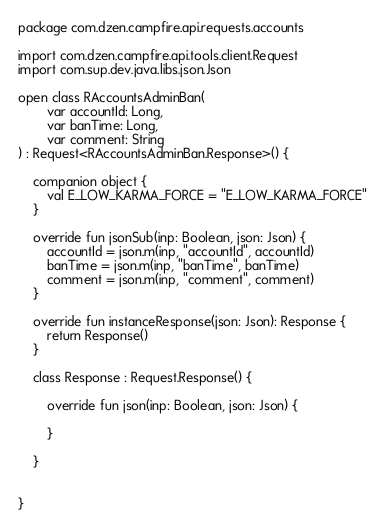<code> <loc_0><loc_0><loc_500><loc_500><_Kotlin_>package com.dzen.campfire.api.requests.accounts

import com.dzen.campfire.api.tools.client.Request
import com.sup.dev.java.libs.json.Json

open class RAccountsAdminBan(
        var accountId: Long,
        var banTime: Long,
        var comment: String
) : Request<RAccountsAdminBan.Response>() {

    companion object {
        val E_LOW_KARMA_FORCE = "E_LOW_KARMA_FORCE"
    }

    override fun jsonSub(inp: Boolean, json: Json) {
        accountId = json.m(inp, "accountId", accountId)
        banTime = json.m(inp, "banTime", banTime)
        comment = json.m(inp, "comment", comment)
    }

    override fun instanceResponse(json: Json): Response {
        return Response()
    }

    class Response : Request.Response() {

        override fun json(inp: Boolean, json: Json) {

        }

    }


}
</code> 